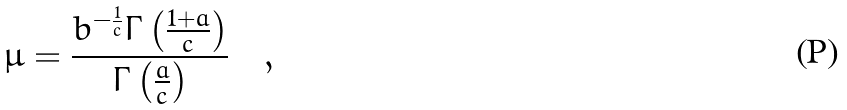<formula> <loc_0><loc_0><loc_500><loc_500>\mu = \frac { { b } ^ { - \frac { 1 } { c } } \Gamma \left ( \frac { 1 + a } { c } \right ) } { \Gamma \left ( { \frac { a } { c } } \right ) } \quad ,</formula> 